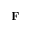Convert formula to latex. <formula><loc_0><loc_0><loc_500><loc_500>F</formula> 